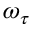<formula> <loc_0><loc_0><loc_500><loc_500>\omega _ { \tau }</formula> 